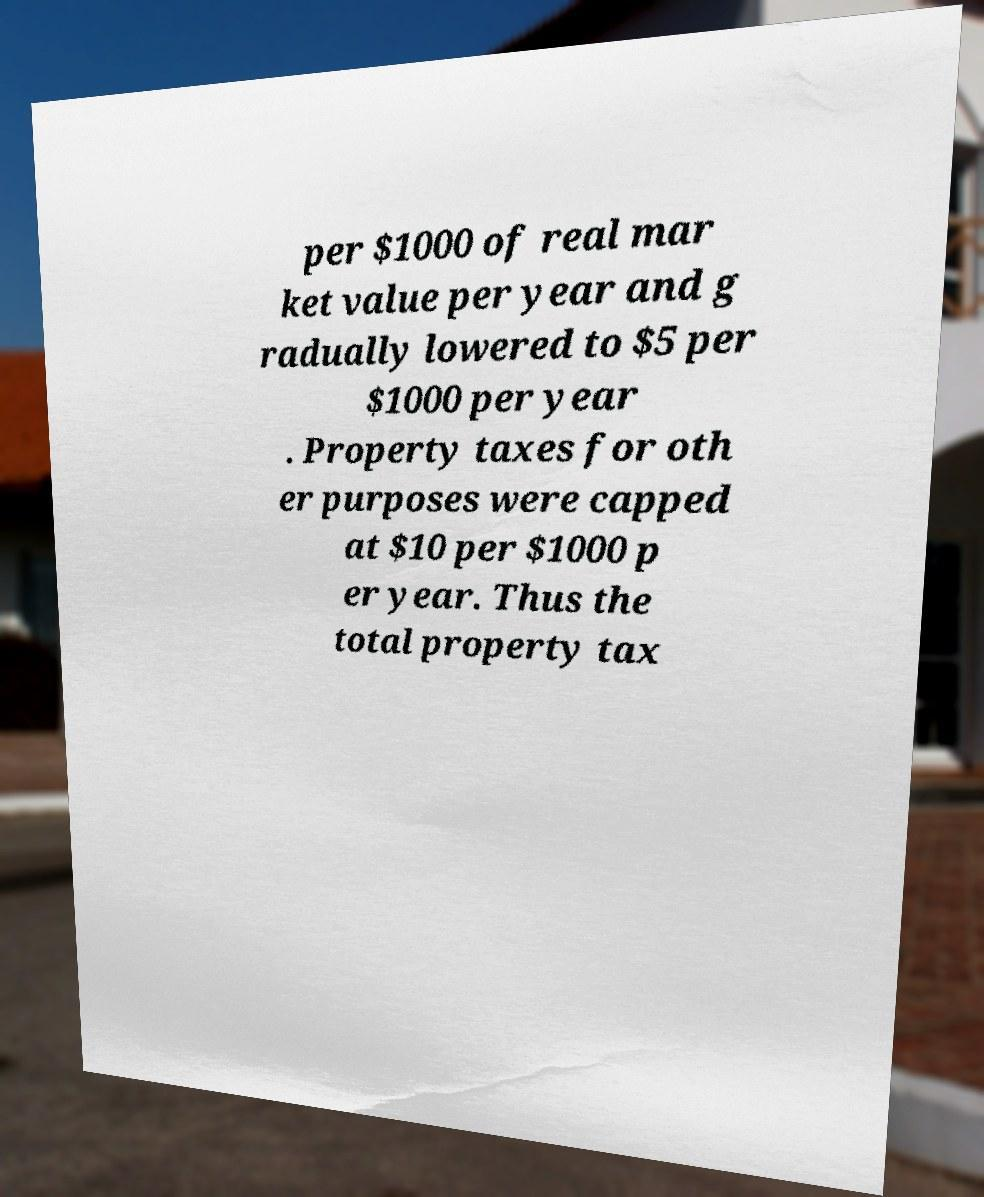Can you accurately transcribe the text from the provided image for me? per $1000 of real mar ket value per year and g radually lowered to $5 per $1000 per year . Property taxes for oth er purposes were capped at $10 per $1000 p er year. Thus the total property tax 